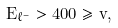<formula> <loc_0><loc_0><loc_500><loc_500>E _ { \ell ^ { - } } > 4 0 0 \geq v ,</formula> 